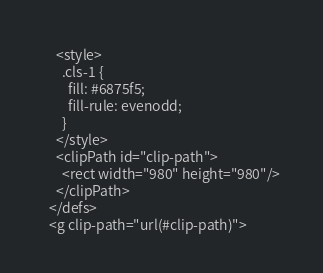<code> <loc_0><loc_0><loc_500><loc_500><_PHP_>    <style>
      .cls-1 {
        fill: #6875f5;
        fill-rule: evenodd;
      }
    </style>
    <clipPath id="clip-path">
      <rect width="980" height="980"/>
    </clipPath>
  </defs>
  <g clip-path="url(#clip-path)"></code> 